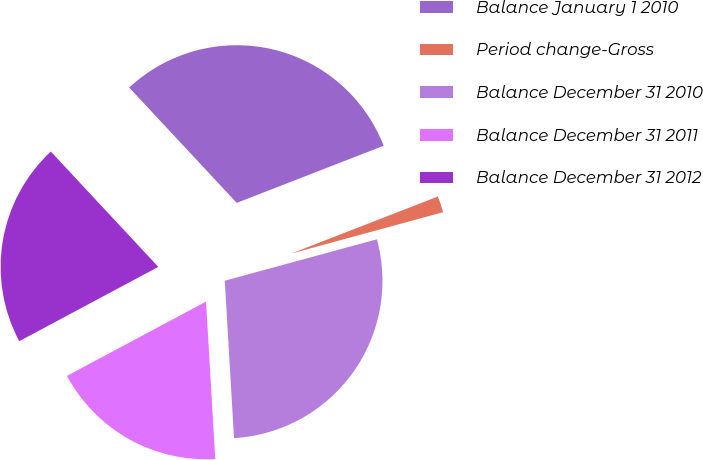<chart> <loc_0><loc_0><loc_500><loc_500><pie_chart><fcel>Balance January 1 2010<fcel>Period change-Gross<fcel>Balance December 31 2010<fcel>Balance December 31 2011<fcel>Balance December 31 2012<nl><fcel>31.04%<fcel>1.67%<fcel>28.3%<fcel>18.12%<fcel>20.87%<nl></chart> 